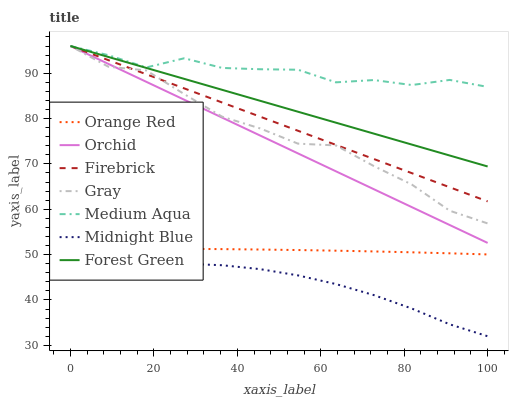Does Midnight Blue have the minimum area under the curve?
Answer yes or no. Yes. Does Medium Aqua have the maximum area under the curve?
Answer yes or no. Yes. Does Firebrick have the minimum area under the curve?
Answer yes or no. No. Does Firebrick have the maximum area under the curve?
Answer yes or no. No. Is Forest Green the smoothest?
Answer yes or no. Yes. Is Medium Aqua the roughest?
Answer yes or no. Yes. Is Midnight Blue the smoothest?
Answer yes or no. No. Is Midnight Blue the roughest?
Answer yes or no. No. Does Midnight Blue have the lowest value?
Answer yes or no. Yes. Does Firebrick have the lowest value?
Answer yes or no. No. Does Orchid have the highest value?
Answer yes or no. Yes. Does Midnight Blue have the highest value?
Answer yes or no. No. Is Midnight Blue less than Orchid?
Answer yes or no. Yes. Is Gray greater than Midnight Blue?
Answer yes or no. Yes. Does Gray intersect Firebrick?
Answer yes or no. Yes. Is Gray less than Firebrick?
Answer yes or no. No. Is Gray greater than Firebrick?
Answer yes or no. No. Does Midnight Blue intersect Orchid?
Answer yes or no. No. 